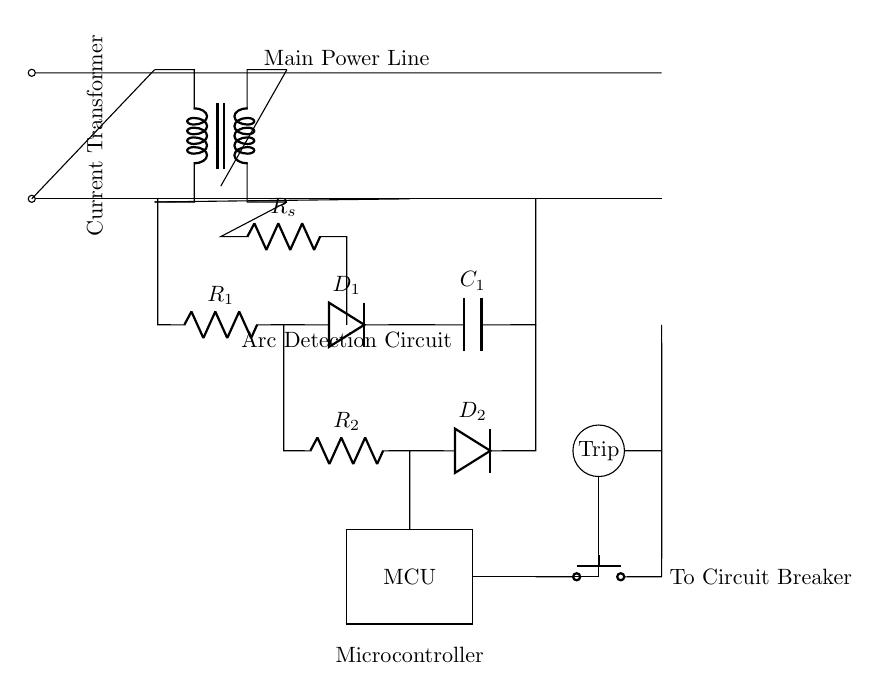What is the function of the microcontroller in this circuit? The microcontroller processes signals from the arc detection circuit and controls the tripping mechanism. It acts as the brain of the operation, determining when an arc is detected and subsequently activating the trip.
Answer: Microcontroller What type of component is used for arc detection in this circuit? The circuit employs resistors and diodes as part of the arc detection circuit, specifically configured to detect fault conditions that caused an arc. The arrangement allows the circuit to sense discrepancies in current flow indicative of an arc.
Answer: Resistors and diodes How many resistors are present in the circuit diagram? There are three resistors visible in the arc fault detection circuit. They are labeled as R1, R2, and Rs, which are critical for current sensing and the arc detection process.
Answer: Three What is the purpose of the current transformer? The current transformer is used to monitor the current flow in the circuit. It detects excessive currents that may indicate an arc fault by comparing the primary current to the secondary current, allowing for the detection of issues in the wiring.
Answer: Current monitoring What happens when the trip button is pressed? Pressing the trip button activates the tripping mechanism, which disconnects the power supply to prevent potential hazards from the detected faults. This action safeguards the electrical system and reduces the risk of fire.
Answer: Disconnects the power supply What do the diodes in the detection circuit do? The diodes allow current to flow in only one direction, preventing reverse current that could damage the system. They play a crucial role in signal processing by ensuring that only the intended current passes through for detection purposes.
Answer: Prevent reverse current 